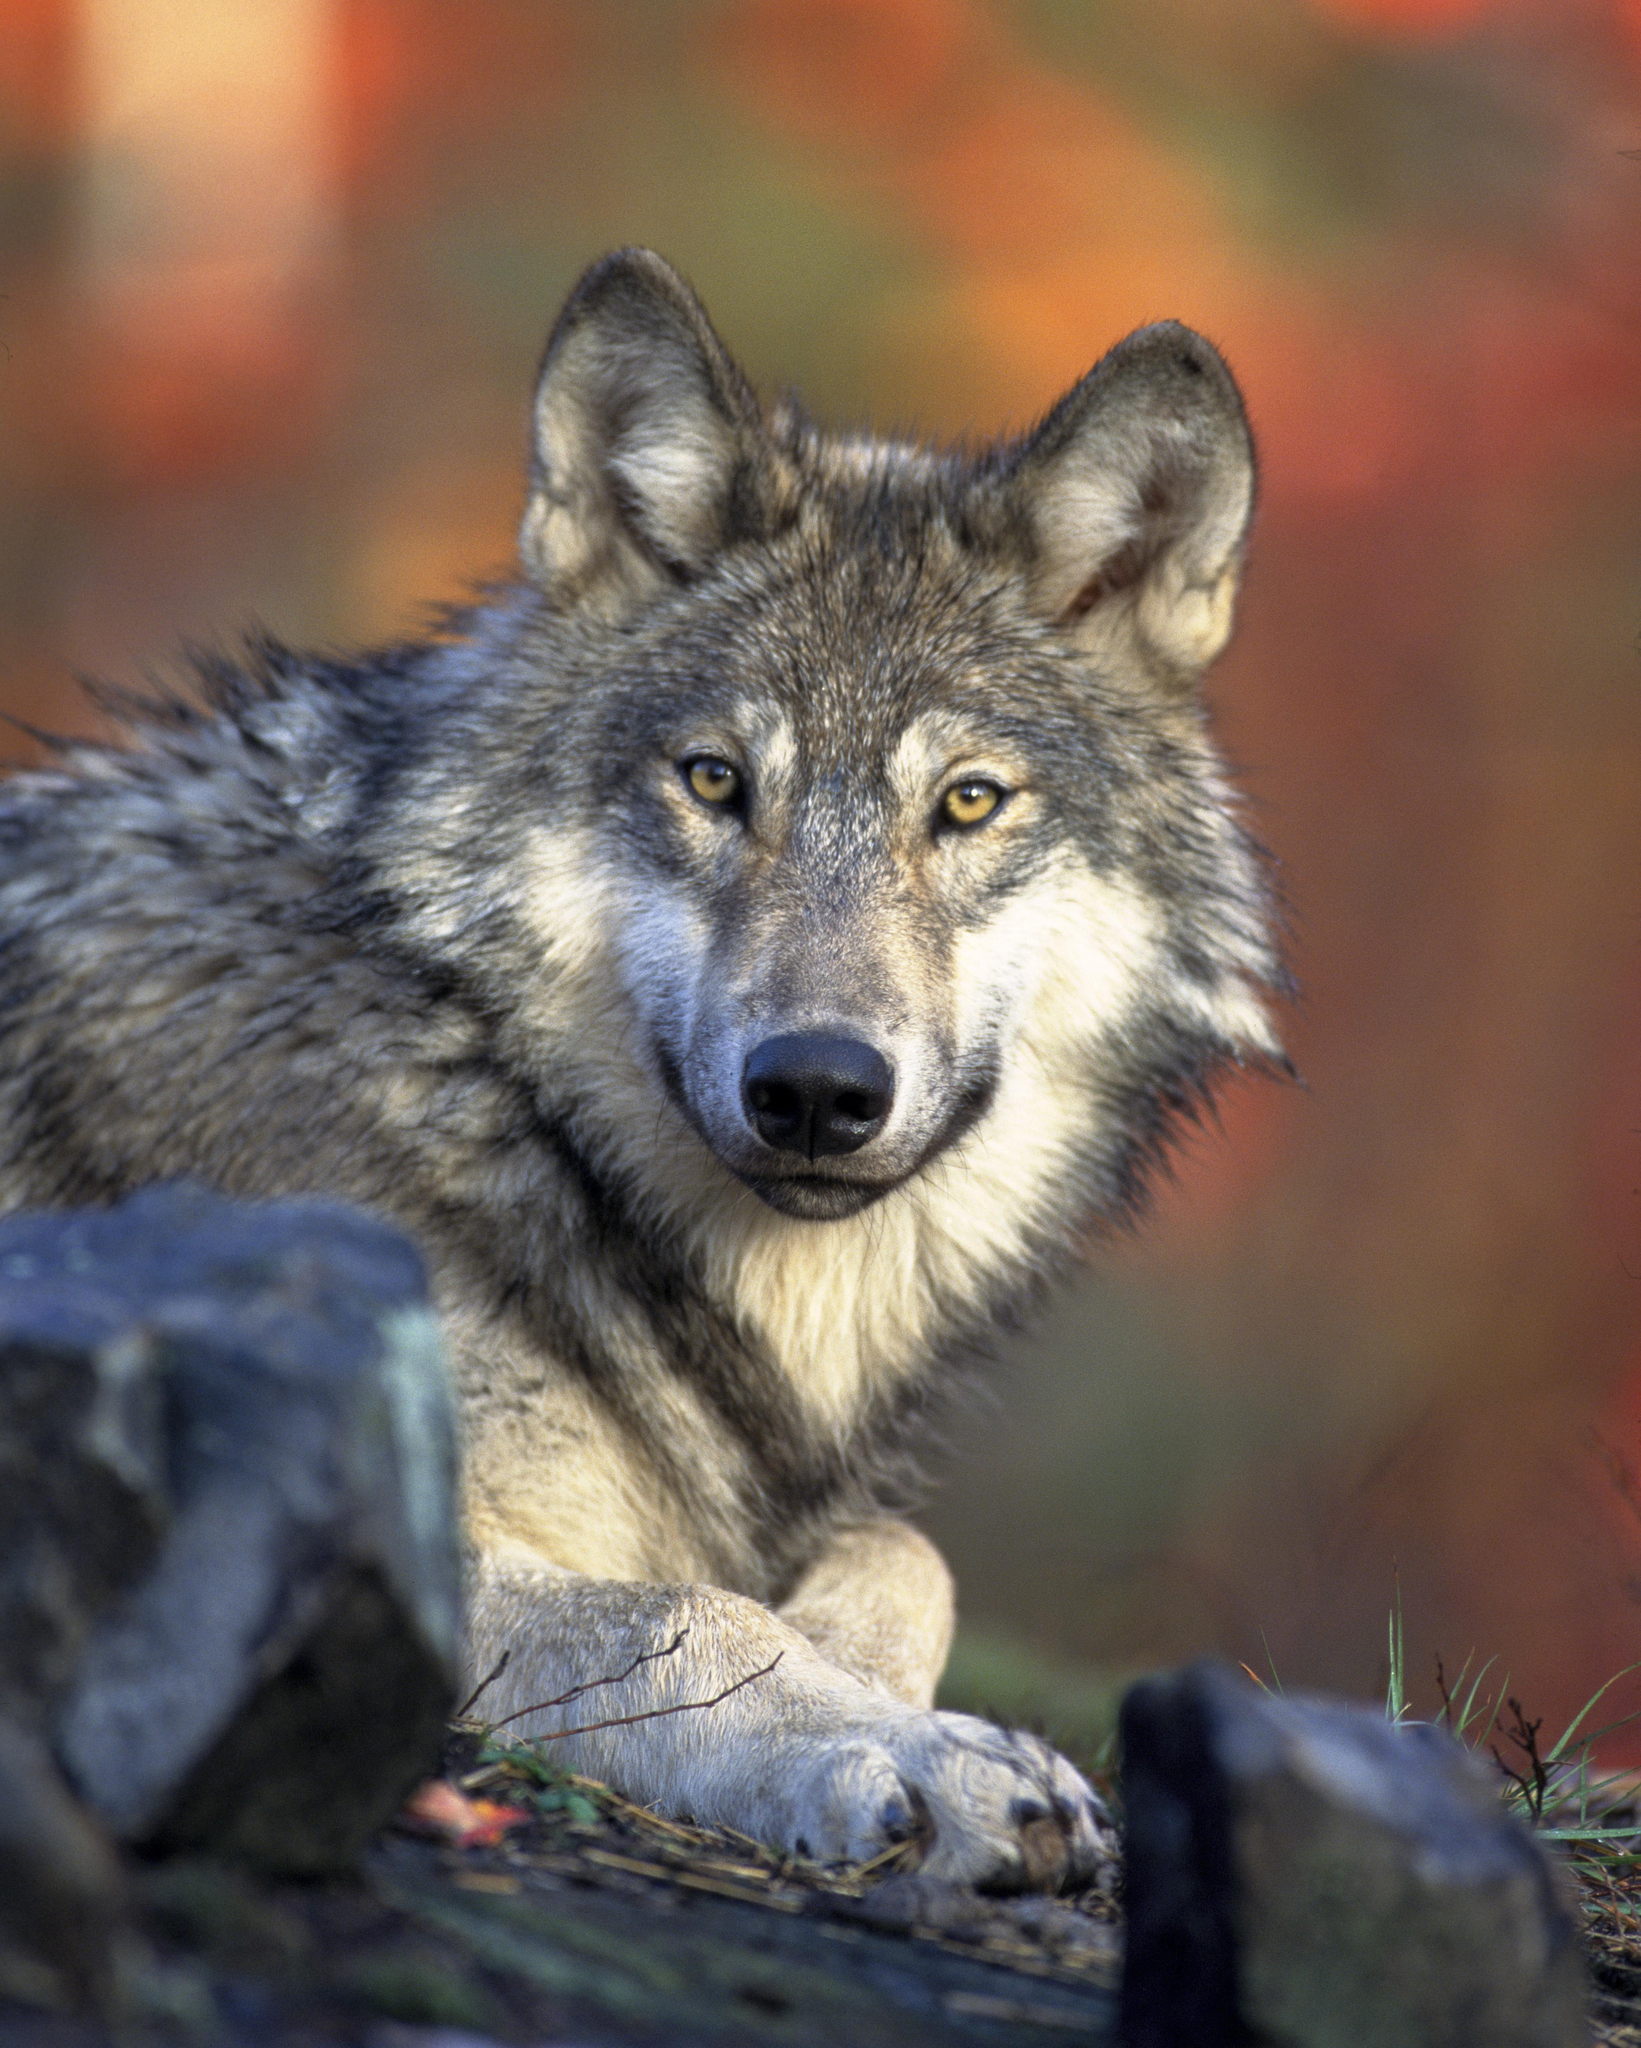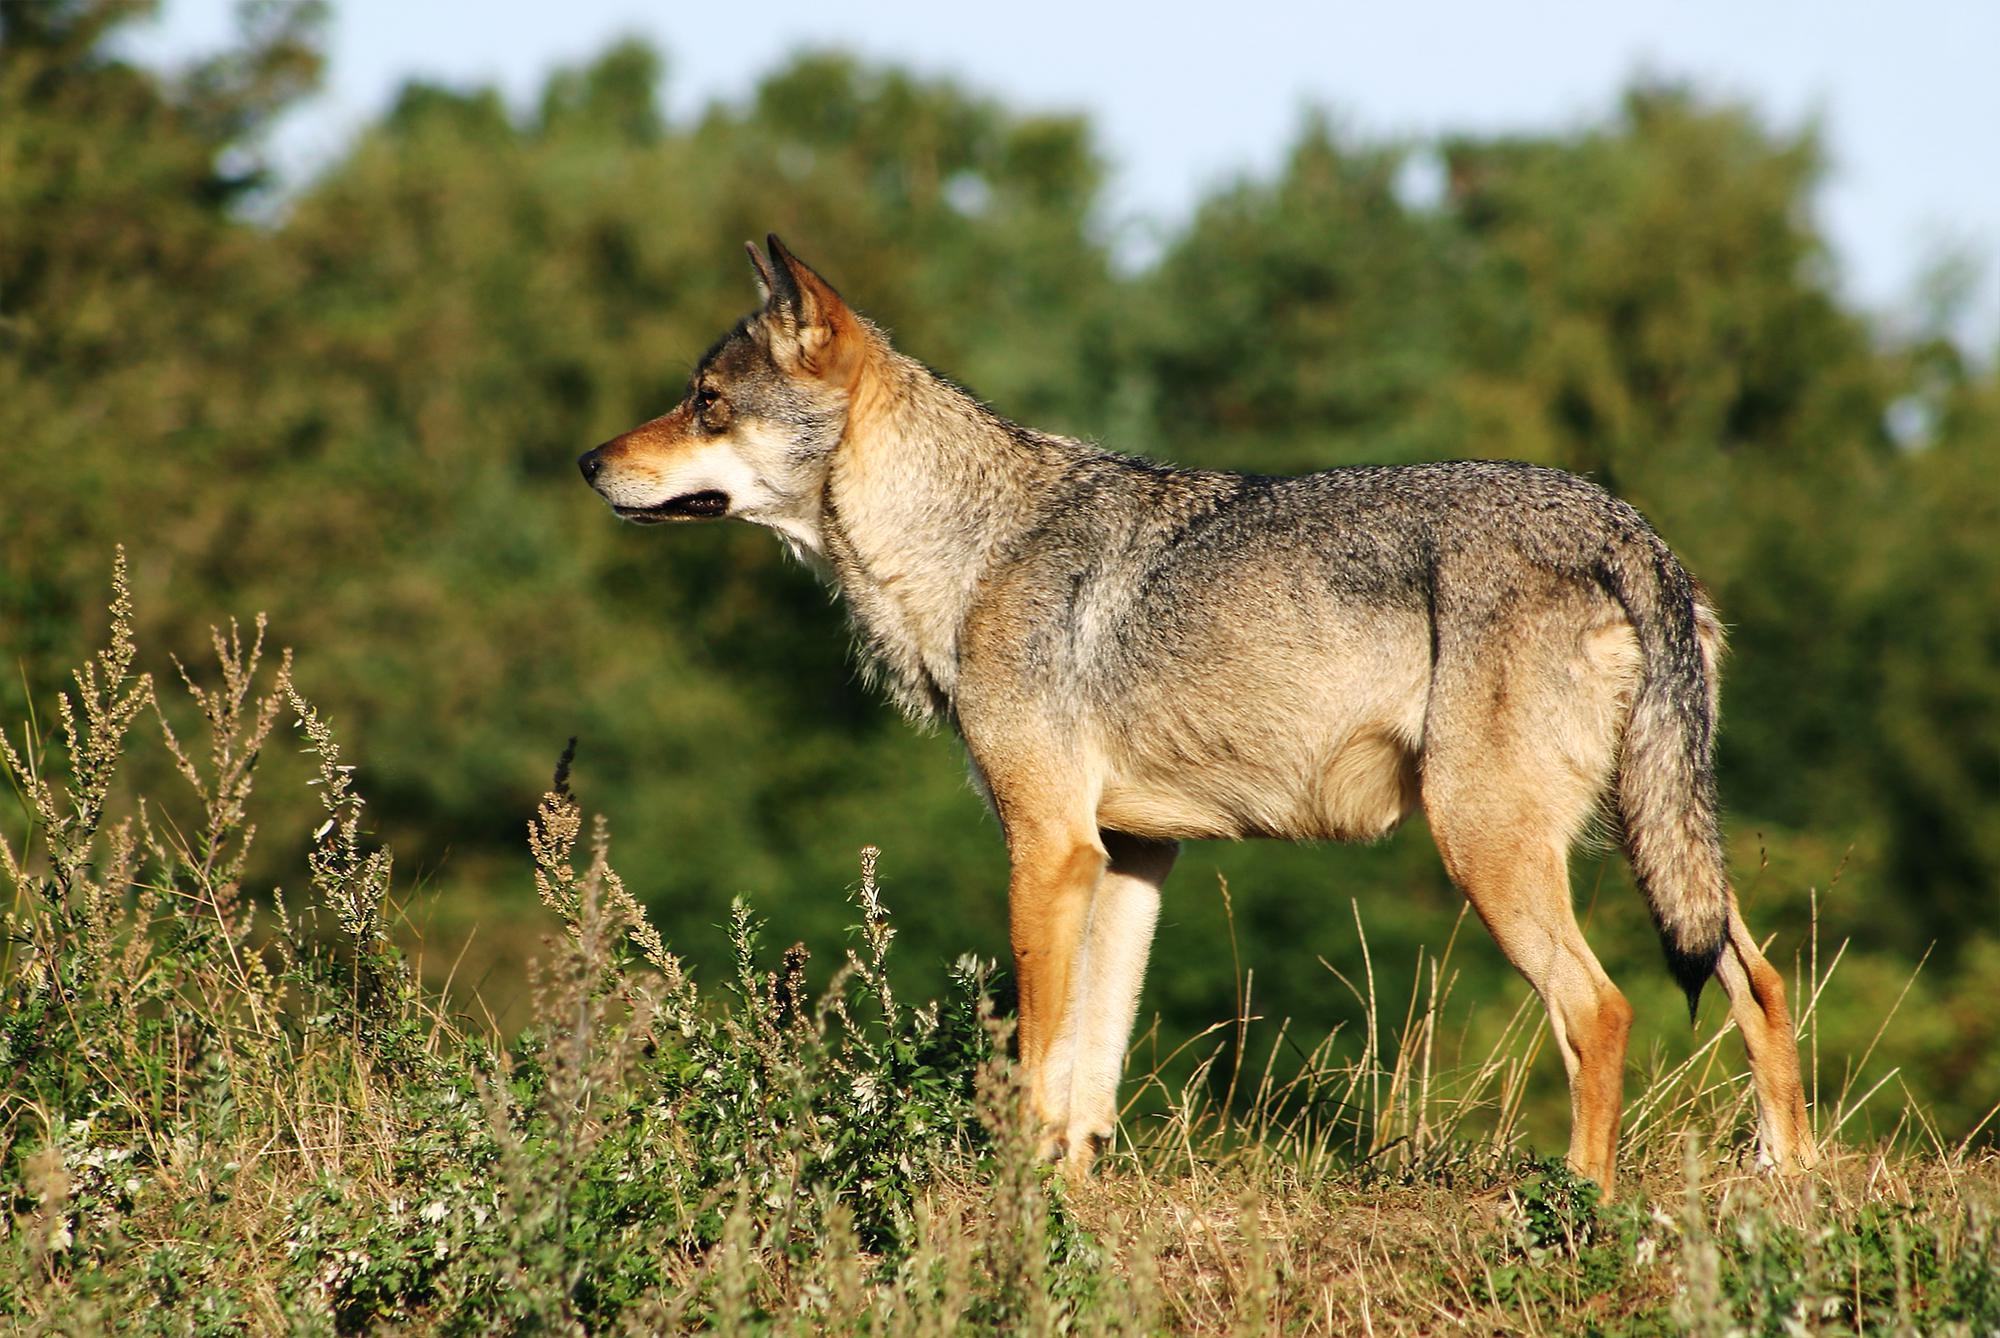The first image is the image on the left, the second image is the image on the right. Given the left and right images, does the statement "An image shows only one wolf, standing with its head and body angled rightward, and leaves visible behind it." hold true? Answer yes or no. No. The first image is the image on the left, the second image is the image on the right. Examine the images to the left and right. Is the description "The wild dog in the image on the left side is lying down on the ground." accurate? Answer yes or no. Yes. 